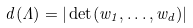<formula> <loc_0><loc_0><loc_500><loc_500>d ( \Lambda ) = | \det ( w _ { 1 } , \dots , w _ { d } ) |</formula> 